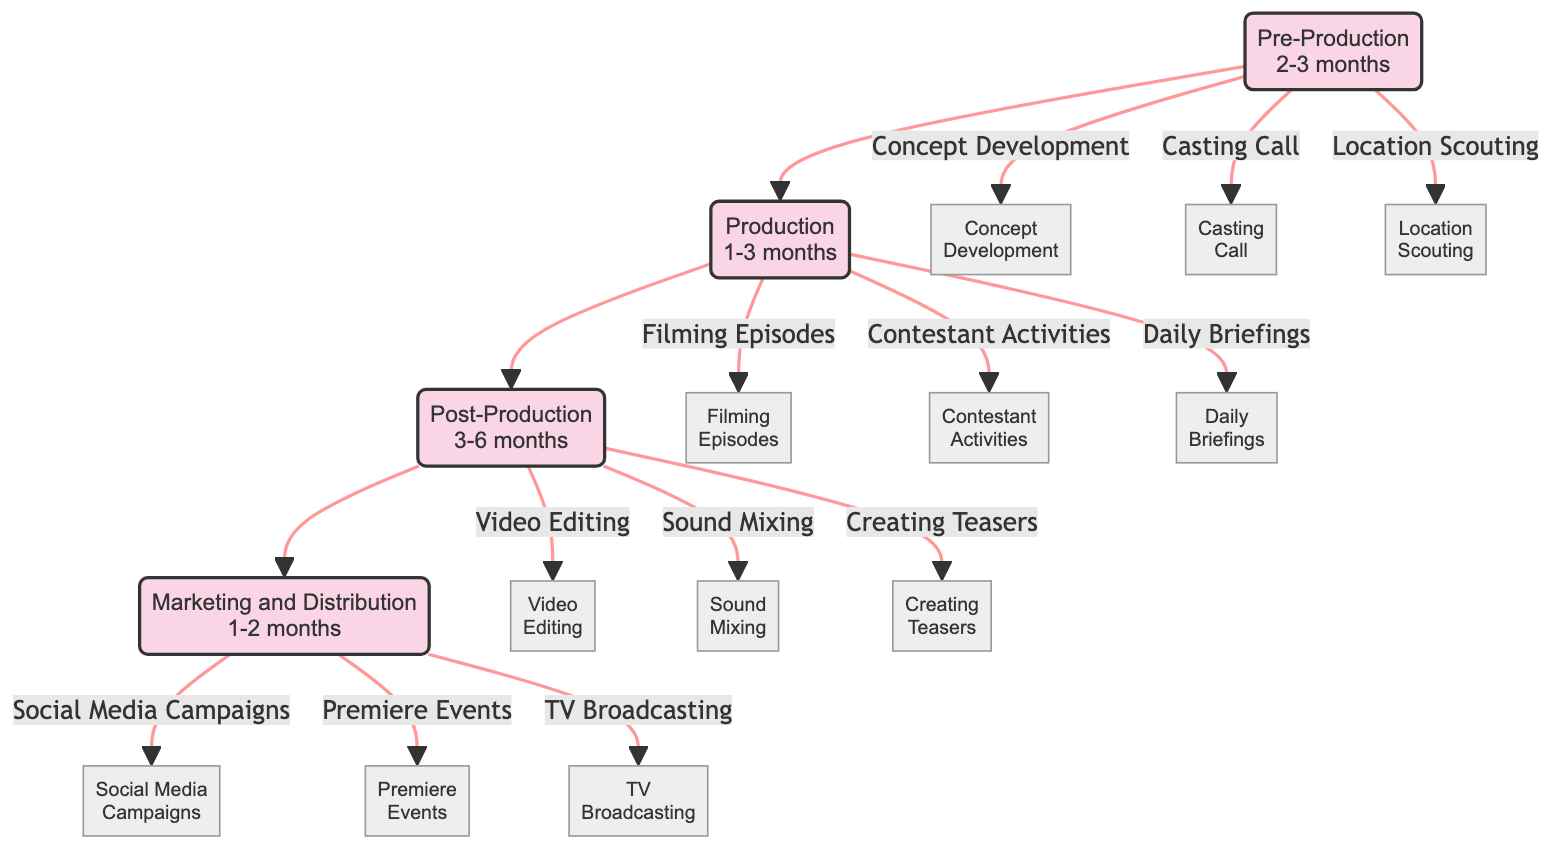What are the key activities in the Pre-Production phase? The diagram lists the key activities for the Pre-Production phase: Concept Development, Budget Planning, Casting Call, Location Scouting, and Contract Negotiation. These activities are directly linked to the Pre-Production node.
Answer: Concept Development, Budget Planning, Casting Call, Location Scouting, Contract Negotiation How many total phases are there in the production of a reality TV show? The diagram has four phases: Pre-Production, Production, Post-Production, and Marketing and Distribution. I counted each phase node visually in the block diagram.
Answer: 4 What is the timeline for the Post-Production phase? The diagram indicates that the timeline for the Post-Production phase is 3-6 months, displayed clearly in the Post-Production box.
Answer: 3-6 months What is the first activity in the Production phase? According to the diagram, the first listed activity under the Production phase is Filming Episodes, as indicated next to the Production node.
Answer: Filming Episodes How does the Marketing and Distribution phase relate to the other phases? The diagram shows that Marketing and Distribution follows the Post-Production phase, indicating a sequential relationship where it happens after the post-production tasks are completed.
Answer: After Post-Production Which activities are associated with the Production phase? The diagram lists Filming Episodes, Directing Scenes, Contestant Activities, Crew Coordination, and Daily Briefings as the key activities under the Production phase, shown under the Production node.
Answer: Filming Episodes, Directing Scenes, Contestant Activities, Crew Coordination, Daily Briefings What activity comes after Video Editing in the Post-Production phase? According to the flow of the diagram, after Video Editing, the next activity is Sound Mixing as it is listed directly beneath the Post-Production node and shows a logical flow.
Answer: Sound Mixing What is the total duration of the phases before Marketing and Distribution? The total duration includes 2-3 months for Pre-Production, 1-3 months for Production, and 3-6 months for Post-Production. Summing the lower ranges yields 2 + 1 + 3 = 6 months, while the upper ranges yield 3 + 3 + 6 = 12 months.
Answer: 6-12 months Which activity is related to Premiere Events? In the Marketing and Distribution phase, Premiere Events is one of the key activities listed, showing the activities planned for the promotion of the show.
Answer: Premiere Events 